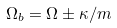Convert formula to latex. <formula><loc_0><loc_0><loc_500><loc_500>\Omega _ { b } = \Omega \pm \kappa / m</formula> 